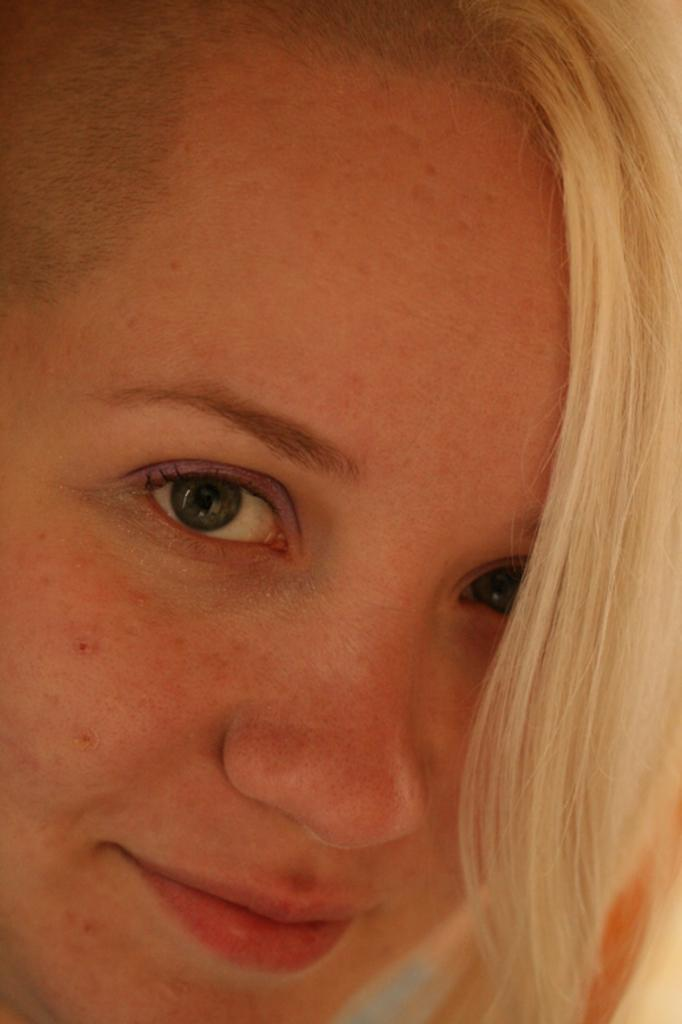What is the main subject in the foreground of the image? There is a woman in the foreground of the image. What type of nest does the woman have in her hobbies? There is no mention of a nest or any hobbies in the image, so it cannot be determined from the image. 